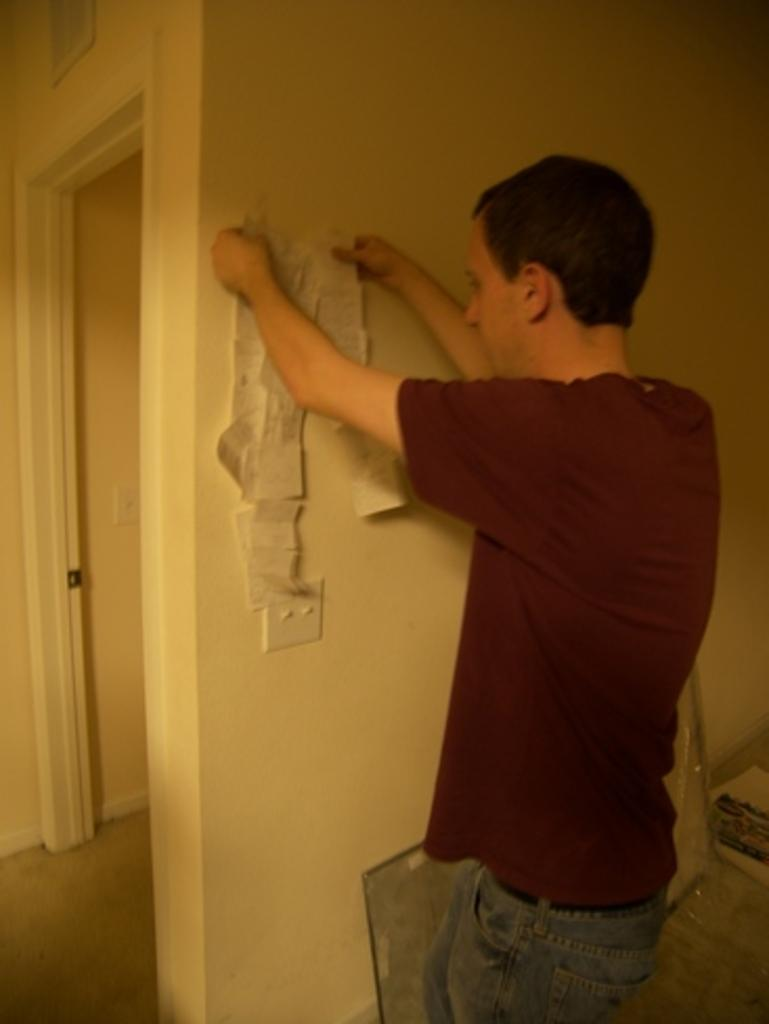What can be seen in the image? There is a person in the image. What is the person wearing? The person is wearing a brown t-shirt and jeans. What is the person doing in the image? The person is standing and holding objects in their hands. What can be seen in the background of the image? There is a cream-colored wall in the background of the image. What type of window can be seen in the image? There is no window present in the image; it features a person standing in front of a cream-colored wall. Is the person part of a team in the image? The image does not provide any information about the person being part of a team or not. 